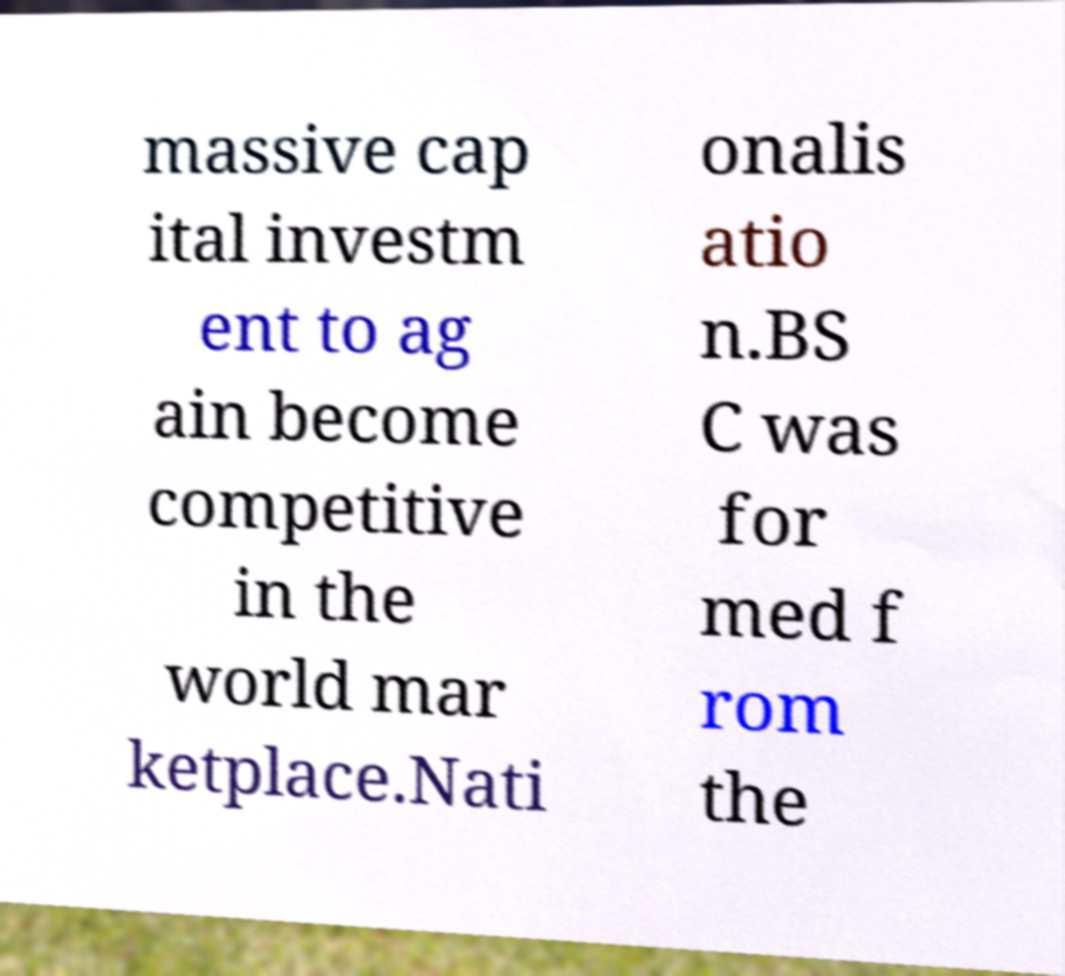For documentation purposes, I need the text within this image transcribed. Could you provide that? massive cap ital investm ent to ag ain become competitive in the world mar ketplace.Nati onalis atio n.BS C was for med f rom the 